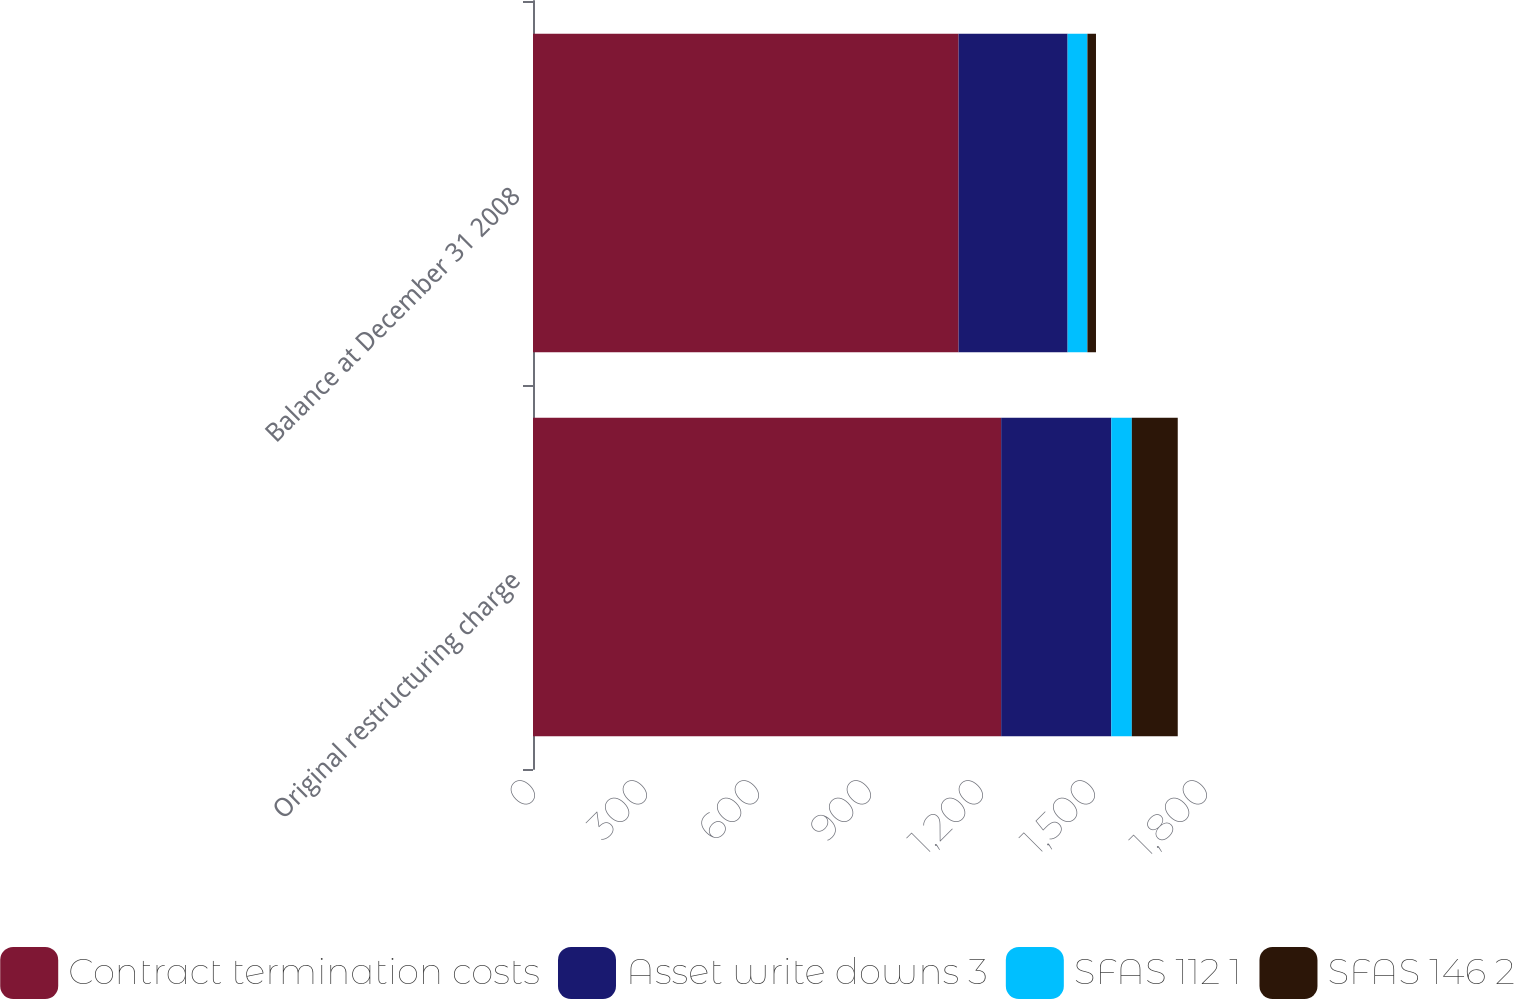Convert chart. <chart><loc_0><loc_0><loc_500><loc_500><stacked_bar_chart><ecel><fcel>Original restructuring charge<fcel>Balance at December 31 2008<nl><fcel>Contract termination costs<fcel>1254<fcel>1140<nl><fcel>Asset write downs 3<fcel>295<fcel>292<nl><fcel>SFAS 112 1<fcel>55<fcel>53<nl><fcel>SFAS 146 2<fcel>123<fcel>23<nl></chart> 